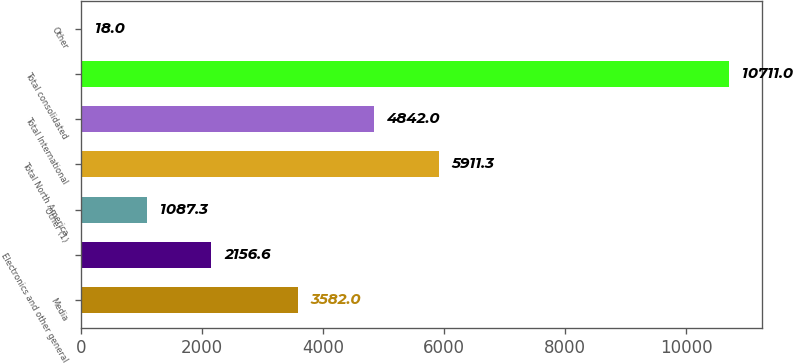<chart> <loc_0><loc_0><loc_500><loc_500><bar_chart><fcel>Media<fcel>Electronics and other general<fcel>Other (1)<fcel>Total North America<fcel>Total International<fcel>Total consolidated<fcel>Other<nl><fcel>3582<fcel>2156.6<fcel>1087.3<fcel>5911.3<fcel>4842<fcel>10711<fcel>18<nl></chart> 